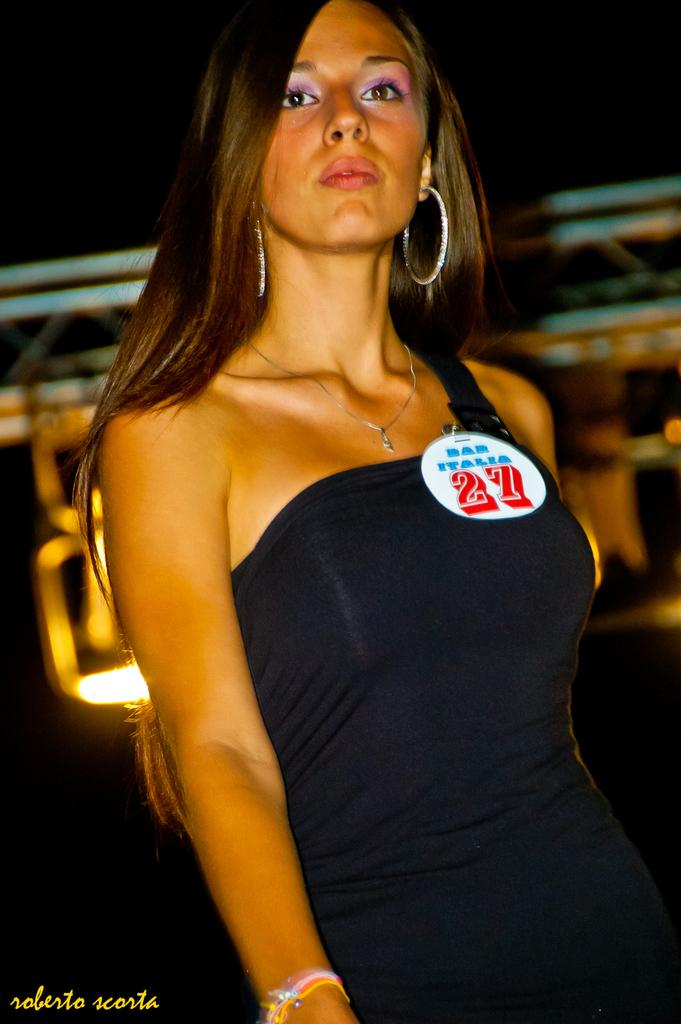Who is the main subject in the image? There is a woman in the image. What can be observed about the background of the image? The background of the image is dark. How many eggs are present in the image? There are no eggs visible in the image. What type of class is being conducted in the image? There is no indication of a class or any educational activity in the image. 